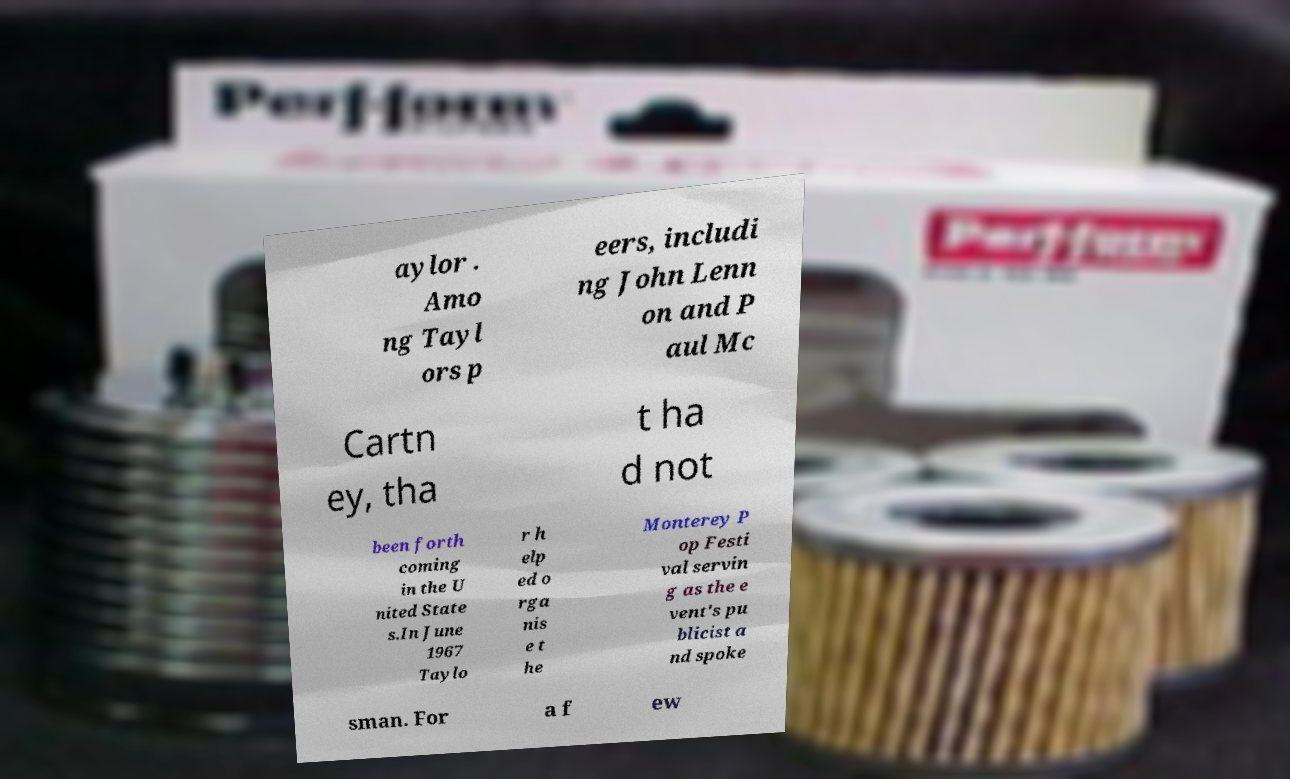I need the written content from this picture converted into text. Can you do that? aylor . Amo ng Tayl ors p eers, includi ng John Lenn on and P aul Mc Cartn ey, tha t ha d not been forth coming in the U nited State s.In June 1967 Taylo r h elp ed o rga nis e t he Monterey P op Festi val servin g as the e vent's pu blicist a nd spoke sman. For a f ew 